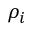<formula> <loc_0><loc_0><loc_500><loc_500>\rho _ { i }</formula> 